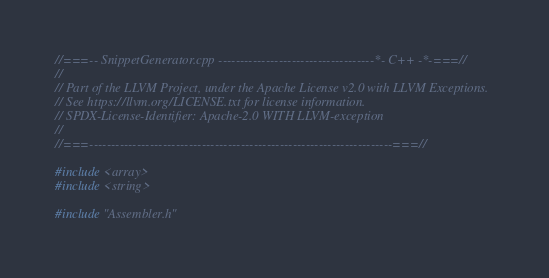Convert code to text. <code><loc_0><loc_0><loc_500><loc_500><_C++_>//===-- SnippetGenerator.cpp ------------------------------------*- C++ -*-===//
//
// Part of the LLVM Project, under the Apache License v2.0 with LLVM Exceptions.
// See https://llvm.org/LICENSE.txt for license information.
// SPDX-License-Identifier: Apache-2.0 WITH LLVM-exception
//
//===----------------------------------------------------------------------===//

#include <array>
#include <string>

#include "Assembler.h"</code> 